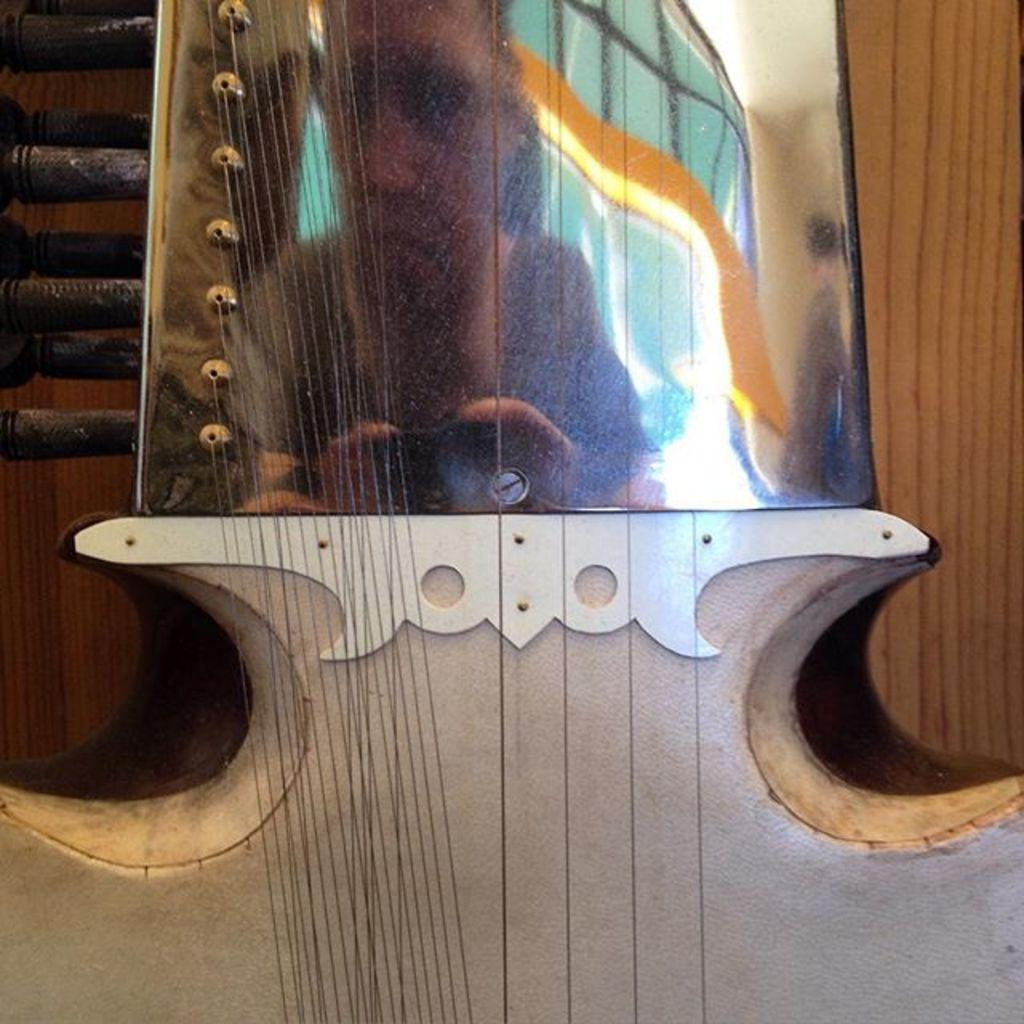What type of musical instrument is in the picture? The musical instrument in the picture has strings attached to it. Can you describe the person visible in the reflection? There is a person visible in the reflection, but no specific details about the person are provided. What can be seen in the background of the picture? A: There is a wall in the background of the picture. What type of joke is being told by the airplane in the picture? There is no airplane present in the picture, so no joke can be attributed to it. 